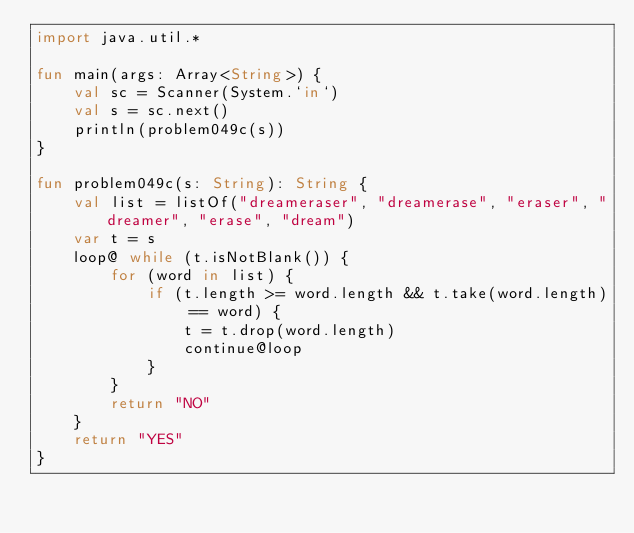Convert code to text. <code><loc_0><loc_0><loc_500><loc_500><_Kotlin_>import java.util.*

fun main(args: Array<String>) {
    val sc = Scanner(System.`in`)
    val s = sc.next()
    println(problem049c(s))
}

fun problem049c(s: String): String {
    val list = listOf("dreameraser", "dreamerase", "eraser", "dreamer", "erase", "dream")
    var t = s
    loop@ while (t.isNotBlank()) {
        for (word in list) {
            if (t.length >= word.length && t.take(word.length) == word) {
                t = t.drop(word.length)
                continue@loop
            }
        }
        return "NO"
    }
    return "YES"
}</code> 